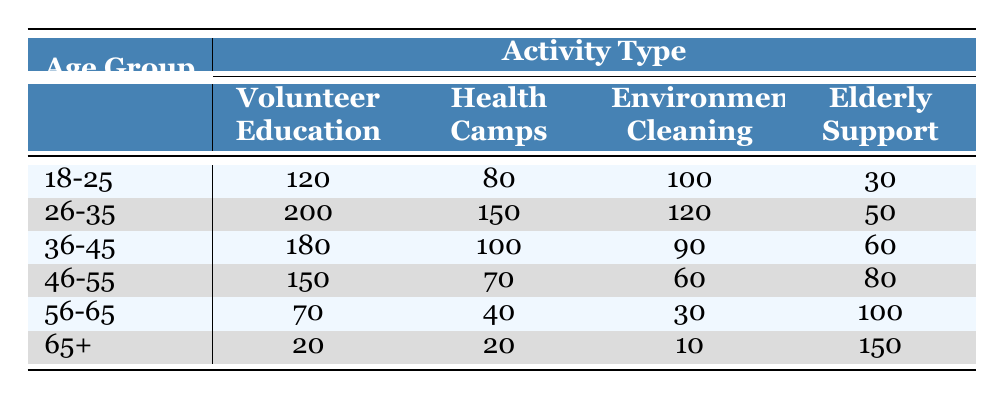What is the total number of participants in Health Camps across all age groups? To find the total number of participants in Health Camps, we will sum the values from the "Health Camps" column: 80 + 150 + 100 + 70 + 40 + 20 = 460.
Answer: 460 Which age group has the highest participation in Elderly Support? The Elderly Support values for each age group are as follows: 30, 50, 60, 80, 100, and 150. The highest value is 150, which belongs to the 65+ age group.
Answer: 65+ What is the difference in participation between the 26-35 age group and the 56-65 age group in Volunteer Education? The participation in Volunteer Education for the 26-35 age group is 200 and for the 56-65 age group is 70. The difference is 200 - 70 = 130.
Answer: 130 Is there a higher participation in Environmental Cleaning for the age group 36-45 compared to the age group 46-55? The values for Environmental Cleaning are 90 for the 36-45 age group and 60 for the 46-55 age group. Since 90 is greater than 60, the statement is true.
Answer: Yes What is the average number of participants in Volunteer Education for those aged 18-25, 36-45, and 46-55? We will first sum the Volunteer Education values for these age groups: 120 (18-25) + 180 (36-45) + 150 (46-55) = 450. There are 3 age groups, so the average is 450/3 = 150.
Answer: 150 Which age group shows the least involvement in Environmental Cleaning? The values for Environmental Cleaning are as follows: 100 (18-25), 120 (26-35), 90 (36-45), 60 (46-55), 30 (56-65), and 10 (65+). The least involvement is 10, which belongs to the 65+ age group.
Answer: 65+ How many more participants are involved in Health Camps from the age group 26-35 compared to the age group 56-65? The participation in Health Camps for 26-35 is 150 and for 56-65 is 40. The difference is 150 - 40 = 110.
Answer: 110 What is the total participation across all age groups in Elderly Support? To find the total for Elderly Support, we sum the values: 30 + 50 + 60 + 80 + 100 + 150 = 470.
Answer: 470 Are the volunteer numbers in Health Camps for the age group 18-25 and 36-45 equal? The numbers are 80 for 18-25 and 100 for 36-45. Since 80 is not equal to 100, the statement is false.
Answer: No 